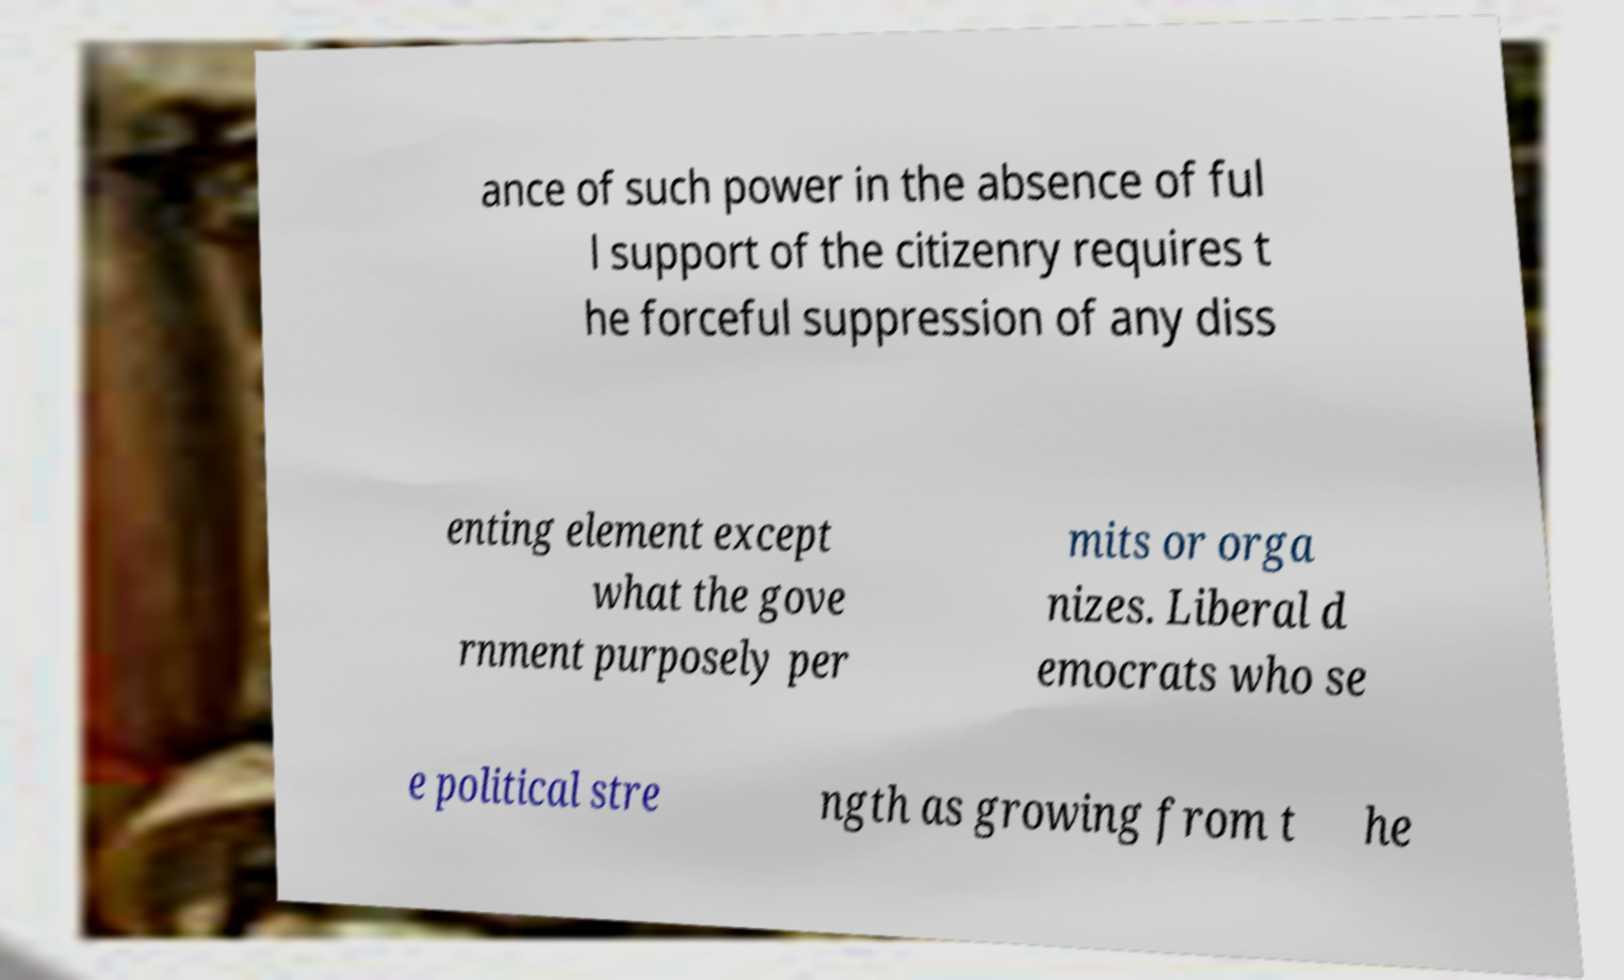Please read and relay the text visible in this image. What does it say? ance of such power in the absence of ful l support of the citizenry requires t he forceful suppression of any diss enting element except what the gove rnment purposely per mits or orga nizes. Liberal d emocrats who se e political stre ngth as growing from t he 